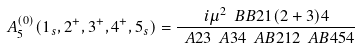Convert formula to latex. <formula><loc_0><loc_0><loc_500><loc_500>A _ { 5 } ^ { ( 0 ) } ( 1 _ { s } , 2 ^ { + } , 3 ^ { + } , 4 ^ { + } , 5 _ { s } ) = \frac { i \mu ^ { 2 } \ B B { 2 } { 1 ( 2 + 3 ) } { 4 } } { \ A 2 3 \ A 3 4 \ A B 2 1 2 \ A B 4 5 4 }</formula> 